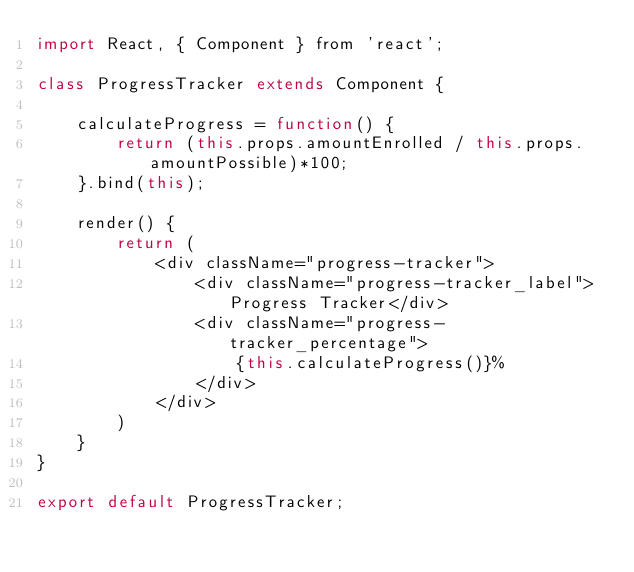<code> <loc_0><loc_0><loc_500><loc_500><_JavaScript_>import React, { Component } from 'react';

class ProgressTracker extends Component {

    calculateProgress = function() {
        return (this.props.amountEnrolled / this.props.amountPossible)*100;
    }.bind(this);

    render() {
        return (
            <div className="progress-tracker">
                <div className="progress-tracker_label">Progress Tracker</div>
                <div className="progress-tracker_percentage">
                    {this.calculateProgress()}%
                </div>
            </div>
        )
    }
}

export default ProgressTracker;
</code> 